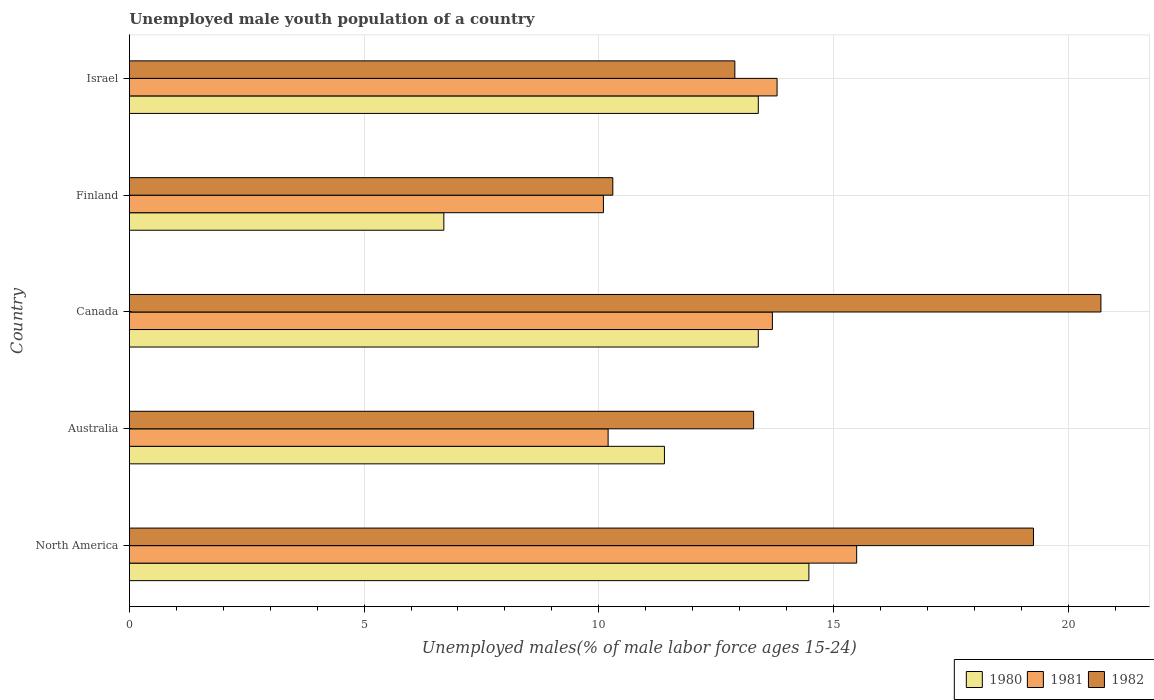Are the number of bars per tick equal to the number of legend labels?
Give a very brief answer. Yes. Are the number of bars on each tick of the Y-axis equal?
Your response must be concise. Yes. How many bars are there on the 1st tick from the top?
Your answer should be very brief. 3. In how many cases, is the number of bars for a given country not equal to the number of legend labels?
Your response must be concise. 0. What is the percentage of unemployed male youth population in 1982 in Australia?
Your answer should be compact. 13.3. Across all countries, what is the maximum percentage of unemployed male youth population in 1980?
Your answer should be compact. 14.48. Across all countries, what is the minimum percentage of unemployed male youth population in 1980?
Offer a terse response. 6.7. In which country was the percentage of unemployed male youth population in 1982 maximum?
Your answer should be compact. Canada. In which country was the percentage of unemployed male youth population in 1982 minimum?
Ensure brevity in your answer.  Finland. What is the total percentage of unemployed male youth population in 1981 in the graph?
Provide a short and direct response. 63.3. What is the difference between the percentage of unemployed male youth population in 1982 in Australia and that in North America?
Make the answer very short. -5.96. What is the difference between the percentage of unemployed male youth population in 1980 in North America and the percentage of unemployed male youth population in 1982 in Canada?
Ensure brevity in your answer.  -6.22. What is the average percentage of unemployed male youth population in 1981 per country?
Your answer should be compact. 12.66. What is the difference between the percentage of unemployed male youth population in 1982 and percentage of unemployed male youth population in 1980 in North America?
Provide a short and direct response. 4.79. In how many countries, is the percentage of unemployed male youth population in 1981 greater than 12 %?
Your response must be concise. 3. What is the ratio of the percentage of unemployed male youth population in 1980 in Canada to that in Finland?
Keep it short and to the point. 2. Is the percentage of unemployed male youth population in 1982 in Finland less than that in Israel?
Ensure brevity in your answer.  Yes. Is the difference between the percentage of unemployed male youth population in 1982 in Australia and Finland greater than the difference between the percentage of unemployed male youth population in 1980 in Australia and Finland?
Your answer should be very brief. No. What is the difference between the highest and the second highest percentage of unemployed male youth population in 1982?
Make the answer very short. 1.44. What is the difference between the highest and the lowest percentage of unemployed male youth population in 1981?
Offer a terse response. 5.4. Is the sum of the percentage of unemployed male youth population in 1982 in Canada and North America greater than the maximum percentage of unemployed male youth population in 1981 across all countries?
Provide a short and direct response. Yes. What does the 2nd bar from the bottom in Finland represents?
Your answer should be compact. 1981. Are all the bars in the graph horizontal?
Provide a short and direct response. Yes. What is the difference between two consecutive major ticks on the X-axis?
Provide a short and direct response. 5. Does the graph contain any zero values?
Your answer should be compact. No. Does the graph contain grids?
Your response must be concise. Yes. Where does the legend appear in the graph?
Your answer should be compact. Bottom right. How many legend labels are there?
Provide a succinct answer. 3. How are the legend labels stacked?
Give a very brief answer. Horizontal. What is the title of the graph?
Make the answer very short. Unemployed male youth population of a country. Does "1980" appear as one of the legend labels in the graph?
Provide a short and direct response. Yes. What is the label or title of the X-axis?
Your answer should be very brief. Unemployed males(% of male labor force ages 15-24). What is the Unemployed males(% of male labor force ages 15-24) in 1980 in North America?
Your answer should be very brief. 14.48. What is the Unemployed males(% of male labor force ages 15-24) in 1981 in North America?
Provide a short and direct response. 15.5. What is the Unemployed males(% of male labor force ages 15-24) in 1982 in North America?
Your answer should be very brief. 19.26. What is the Unemployed males(% of male labor force ages 15-24) in 1980 in Australia?
Your response must be concise. 11.4. What is the Unemployed males(% of male labor force ages 15-24) of 1981 in Australia?
Make the answer very short. 10.2. What is the Unemployed males(% of male labor force ages 15-24) in 1982 in Australia?
Offer a terse response. 13.3. What is the Unemployed males(% of male labor force ages 15-24) in 1980 in Canada?
Offer a terse response. 13.4. What is the Unemployed males(% of male labor force ages 15-24) of 1981 in Canada?
Your answer should be very brief. 13.7. What is the Unemployed males(% of male labor force ages 15-24) in 1982 in Canada?
Provide a short and direct response. 20.7. What is the Unemployed males(% of male labor force ages 15-24) of 1980 in Finland?
Offer a terse response. 6.7. What is the Unemployed males(% of male labor force ages 15-24) in 1981 in Finland?
Provide a succinct answer. 10.1. What is the Unemployed males(% of male labor force ages 15-24) of 1982 in Finland?
Your answer should be compact. 10.3. What is the Unemployed males(% of male labor force ages 15-24) of 1980 in Israel?
Ensure brevity in your answer.  13.4. What is the Unemployed males(% of male labor force ages 15-24) in 1981 in Israel?
Ensure brevity in your answer.  13.8. What is the Unemployed males(% of male labor force ages 15-24) of 1982 in Israel?
Give a very brief answer. 12.9. Across all countries, what is the maximum Unemployed males(% of male labor force ages 15-24) in 1980?
Make the answer very short. 14.48. Across all countries, what is the maximum Unemployed males(% of male labor force ages 15-24) of 1981?
Your answer should be compact. 15.5. Across all countries, what is the maximum Unemployed males(% of male labor force ages 15-24) in 1982?
Provide a succinct answer. 20.7. Across all countries, what is the minimum Unemployed males(% of male labor force ages 15-24) of 1980?
Ensure brevity in your answer.  6.7. Across all countries, what is the minimum Unemployed males(% of male labor force ages 15-24) in 1981?
Your answer should be very brief. 10.1. Across all countries, what is the minimum Unemployed males(% of male labor force ages 15-24) of 1982?
Give a very brief answer. 10.3. What is the total Unemployed males(% of male labor force ages 15-24) in 1980 in the graph?
Give a very brief answer. 59.38. What is the total Unemployed males(% of male labor force ages 15-24) in 1981 in the graph?
Provide a short and direct response. 63.3. What is the total Unemployed males(% of male labor force ages 15-24) in 1982 in the graph?
Provide a short and direct response. 76.46. What is the difference between the Unemployed males(% of male labor force ages 15-24) in 1980 in North America and that in Australia?
Your answer should be compact. 3.08. What is the difference between the Unemployed males(% of male labor force ages 15-24) in 1981 in North America and that in Australia?
Your answer should be compact. 5.3. What is the difference between the Unemployed males(% of male labor force ages 15-24) in 1982 in North America and that in Australia?
Offer a terse response. 5.96. What is the difference between the Unemployed males(% of male labor force ages 15-24) in 1980 in North America and that in Canada?
Keep it short and to the point. 1.08. What is the difference between the Unemployed males(% of male labor force ages 15-24) of 1981 in North America and that in Canada?
Keep it short and to the point. 1.8. What is the difference between the Unemployed males(% of male labor force ages 15-24) in 1982 in North America and that in Canada?
Offer a very short reply. -1.44. What is the difference between the Unemployed males(% of male labor force ages 15-24) of 1980 in North America and that in Finland?
Your answer should be compact. 7.78. What is the difference between the Unemployed males(% of male labor force ages 15-24) of 1981 in North America and that in Finland?
Keep it short and to the point. 5.4. What is the difference between the Unemployed males(% of male labor force ages 15-24) of 1982 in North America and that in Finland?
Your response must be concise. 8.96. What is the difference between the Unemployed males(% of male labor force ages 15-24) of 1980 in North America and that in Israel?
Keep it short and to the point. 1.08. What is the difference between the Unemployed males(% of male labor force ages 15-24) of 1981 in North America and that in Israel?
Provide a succinct answer. 1.7. What is the difference between the Unemployed males(% of male labor force ages 15-24) of 1982 in North America and that in Israel?
Offer a terse response. 6.36. What is the difference between the Unemployed males(% of male labor force ages 15-24) in 1980 in Australia and that in Canada?
Your answer should be very brief. -2. What is the difference between the Unemployed males(% of male labor force ages 15-24) of 1982 in Australia and that in Canada?
Your response must be concise. -7.4. What is the difference between the Unemployed males(% of male labor force ages 15-24) in 1982 in Australia and that in Finland?
Your response must be concise. 3. What is the difference between the Unemployed males(% of male labor force ages 15-24) of 1981 in Australia and that in Israel?
Offer a terse response. -3.6. What is the difference between the Unemployed males(% of male labor force ages 15-24) of 1981 in Canada and that in Finland?
Offer a terse response. 3.6. What is the difference between the Unemployed males(% of male labor force ages 15-24) in 1980 in Canada and that in Israel?
Provide a succinct answer. 0. What is the difference between the Unemployed males(% of male labor force ages 15-24) of 1982 in Finland and that in Israel?
Provide a short and direct response. -2.6. What is the difference between the Unemployed males(% of male labor force ages 15-24) of 1980 in North America and the Unemployed males(% of male labor force ages 15-24) of 1981 in Australia?
Give a very brief answer. 4.28. What is the difference between the Unemployed males(% of male labor force ages 15-24) of 1980 in North America and the Unemployed males(% of male labor force ages 15-24) of 1982 in Australia?
Keep it short and to the point. 1.18. What is the difference between the Unemployed males(% of male labor force ages 15-24) in 1981 in North America and the Unemployed males(% of male labor force ages 15-24) in 1982 in Australia?
Give a very brief answer. 2.2. What is the difference between the Unemployed males(% of male labor force ages 15-24) of 1980 in North America and the Unemployed males(% of male labor force ages 15-24) of 1981 in Canada?
Your response must be concise. 0.78. What is the difference between the Unemployed males(% of male labor force ages 15-24) in 1980 in North America and the Unemployed males(% of male labor force ages 15-24) in 1982 in Canada?
Your answer should be very brief. -6.22. What is the difference between the Unemployed males(% of male labor force ages 15-24) of 1981 in North America and the Unemployed males(% of male labor force ages 15-24) of 1982 in Canada?
Give a very brief answer. -5.2. What is the difference between the Unemployed males(% of male labor force ages 15-24) of 1980 in North America and the Unemployed males(% of male labor force ages 15-24) of 1981 in Finland?
Offer a very short reply. 4.38. What is the difference between the Unemployed males(% of male labor force ages 15-24) in 1980 in North America and the Unemployed males(% of male labor force ages 15-24) in 1982 in Finland?
Your answer should be compact. 4.18. What is the difference between the Unemployed males(% of male labor force ages 15-24) in 1981 in North America and the Unemployed males(% of male labor force ages 15-24) in 1982 in Finland?
Offer a terse response. 5.2. What is the difference between the Unemployed males(% of male labor force ages 15-24) in 1980 in North America and the Unemployed males(% of male labor force ages 15-24) in 1981 in Israel?
Offer a very short reply. 0.68. What is the difference between the Unemployed males(% of male labor force ages 15-24) in 1980 in North America and the Unemployed males(% of male labor force ages 15-24) in 1982 in Israel?
Ensure brevity in your answer.  1.58. What is the difference between the Unemployed males(% of male labor force ages 15-24) of 1981 in North America and the Unemployed males(% of male labor force ages 15-24) of 1982 in Israel?
Provide a succinct answer. 2.6. What is the difference between the Unemployed males(% of male labor force ages 15-24) of 1980 in Australia and the Unemployed males(% of male labor force ages 15-24) of 1982 in Canada?
Offer a very short reply. -9.3. What is the difference between the Unemployed males(% of male labor force ages 15-24) of 1980 in Australia and the Unemployed males(% of male labor force ages 15-24) of 1981 in Finland?
Give a very brief answer. 1.3. What is the difference between the Unemployed males(% of male labor force ages 15-24) of 1980 in Australia and the Unemployed males(% of male labor force ages 15-24) of 1982 in Israel?
Keep it short and to the point. -1.5. What is the difference between the Unemployed males(% of male labor force ages 15-24) in 1980 in Canada and the Unemployed males(% of male labor force ages 15-24) in 1981 in Finland?
Give a very brief answer. 3.3. What is the difference between the Unemployed males(% of male labor force ages 15-24) in 1980 in Canada and the Unemployed males(% of male labor force ages 15-24) in 1982 in Finland?
Give a very brief answer. 3.1. What is the difference between the Unemployed males(% of male labor force ages 15-24) in 1980 in Canada and the Unemployed males(% of male labor force ages 15-24) in 1982 in Israel?
Give a very brief answer. 0.5. What is the difference between the Unemployed males(% of male labor force ages 15-24) in 1980 in Finland and the Unemployed males(% of male labor force ages 15-24) in 1981 in Israel?
Offer a terse response. -7.1. What is the difference between the Unemployed males(% of male labor force ages 15-24) in 1981 in Finland and the Unemployed males(% of male labor force ages 15-24) in 1982 in Israel?
Your answer should be very brief. -2.8. What is the average Unemployed males(% of male labor force ages 15-24) in 1980 per country?
Offer a terse response. 11.88. What is the average Unemployed males(% of male labor force ages 15-24) of 1981 per country?
Your answer should be compact. 12.66. What is the average Unemployed males(% of male labor force ages 15-24) of 1982 per country?
Your response must be concise. 15.29. What is the difference between the Unemployed males(% of male labor force ages 15-24) of 1980 and Unemployed males(% of male labor force ages 15-24) of 1981 in North America?
Keep it short and to the point. -1.02. What is the difference between the Unemployed males(% of male labor force ages 15-24) of 1980 and Unemployed males(% of male labor force ages 15-24) of 1982 in North America?
Your answer should be very brief. -4.79. What is the difference between the Unemployed males(% of male labor force ages 15-24) in 1981 and Unemployed males(% of male labor force ages 15-24) in 1982 in North America?
Your answer should be very brief. -3.77. What is the difference between the Unemployed males(% of male labor force ages 15-24) of 1980 and Unemployed males(% of male labor force ages 15-24) of 1982 in Australia?
Keep it short and to the point. -1.9. What is the difference between the Unemployed males(% of male labor force ages 15-24) of 1981 and Unemployed males(% of male labor force ages 15-24) of 1982 in Australia?
Keep it short and to the point. -3.1. What is the difference between the Unemployed males(% of male labor force ages 15-24) in 1980 and Unemployed males(% of male labor force ages 15-24) in 1981 in Canada?
Keep it short and to the point. -0.3. What is the difference between the Unemployed males(% of male labor force ages 15-24) of 1980 and Unemployed males(% of male labor force ages 15-24) of 1982 in Canada?
Your answer should be very brief. -7.3. What is the difference between the Unemployed males(% of male labor force ages 15-24) in 1981 and Unemployed males(% of male labor force ages 15-24) in 1982 in Canada?
Keep it short and to the point. -7. What is the difference between the Unemployed males(% of male labor force ages 15-24) in 1980 and Unemployed males(% of male labor force ages 15-24) in 1981 in Finland?
Provide a short and direct response. -3.4. What is the difference between the Unemployed males(% of male labor force ages 15-24) in 1981 and Unemployed males(% of male labor force ages 15-24) in 1982 in Finland?
Your response must be concise. -0.2. What is the difference between the Unemployed males(% of male labor force ages 15-24) in 1980 and Unemployed males(% of male labor force ages 15-24) in 1982 in Israel?
Give a very brief answer. 0.5. What is the ratio of the Unemployed males(% of male labor force ages 15-24) of 1980 in North America to that in Australia?
Keep it short and to the point. 1.27. What is the ratio of the Unemployed males(% of male labor force ages 15-24) in 1981 in North America to that in Australia?
Offer a very short reply. 1.52. What is the ratio of the Unemployed males(% of male labor force ages 15-24) in 1982 in North America to that in Australia?
Provide a succinct answer. 1.45. What is the ratio of the Unemployed males(% of male labor force ages 15-24) of 1980 in North America to that in Canada?
Your answer should be very brief. 1.08. What is the ratio of the Unemployed males(% of male labor force ages 15-24) of 1981 in North America to that in Canada?
Keep it short and to the point. 1.13. What is the ratio of the Unemployed males(% of male labor force ages 15-24) in 1982 in North America to that in Canada?
Provide a succinct answer. 0.93. What is the ratio of the Unemployed males(% of male labor force ages 15-24) in 1980 in North America to that in Finland?
Provide a short and direct response. 2.16. What is the ratio of the Unemployed males(% of male labor force ages 15-24) in 1981 in North America to that in Finland?
Offer a very short reply. 1.53. What is the ratio of the Unemployed males(% of male labor force ages 15-24) in 1982 in North America to that in Finland?
Give a very brief answer. 1.87. What is the ratio of the Unemployed males(% of male labor force ages 15-24) of 1980 in North America to that in Israel?
Ensure brevity in your answer.  1.08. What is the ratio of the Unemployed males(% of male labor force ages 15-24) in 1981 in North America to that in Israel?
Provide a short and direct response. 1.12. What is the ratio of the Unemployed males(% of male labor force ages 15-24) in 1982 in North America to that in Israel?
Offer a terse response. 1.49. What is the ratio of the Unemployed males(% of male labor force ages 15-24) of 1980 in Australia to that in Canada?
Your answer should be very brief. 0.85. What is the ratio of the Unemployed males(% of male labor force ages 15-24) in 1981 in Australia to that in Canada?
Provide a short and direct response. 0.74. What is the ratio of the Unemployed males(% of male labor force ages 15-24) in 1982 in Australia to that in Canada?
Offer a terse response. 0.64. What is the ratio of the Unemployed males(% of male labor force ages 15-24) in 1980 in Australia to that in Finland?
Offer a terse response. 1.7. What is the ratio of the Unemployed males(% of male labor force ages 15-24) in 1981 in Australia to that in Finland?
Your answer should be very brief. 1.01. What is the ratio of the Unemployed males(% of male labor force ages 15-24) in 1982 in Australia to that in Finland?
Keep it short and to the point. 1.29. What is the ratio of the Unemployed males(% of male labor force ages 15-24) in 1980 in Australia to that in Israel?
Provide a short and direct response. 0.85. What is the ratio of the Unemployed males(% of male labor force ages 15-24) of 1981 in Australia to that in Israel?
Offer a very short reply. 0.74. What is the ratio of the Unemployed males(% of male labor force ages 15-24) in 1982 in Australia to that in Israel?
Provide a succinct answer. 1.03. What is the ratio of the Unemployed males(% of male labor force ages 15-24) in 1980 in Canada to that in Finland?
Give a very brief answer. 2. What is the ratio of the Unemployed males(% of male labor force ages 15-24) in 1981 in Canada to that in Finland?
Give a very brief answer. 1.36. What is the ratio of the Unemployed males(% of male labor force ages 15-24) in 1982 in Canada to that in Finland?
Make the answer very short. 2.01. What is the ratio of the Unemployed males(% of male labor force ages 15-24) of 1980 in Canada to that in Israel?
Your answer should be compact. 1. What is the ratio of the Unemployed males(% of male labor force ages 15-24) in 1982 in Canada to that in Israel?
Your response must be concise. 1.6. What is the ratio of the Unemployed males(% of male labor force ages 15-24) in 1981 in Finland to that in Israel?
Your answer should be compact. 0.73. What is the ratio of the Unemployed males(% of male labor force ages 15-24) in 1982 in Finland to that in Israel?
Offer a terse response. 0.8. What is the difference between the highest and the second highest Unemployed males(% of male labor force ages 15-24) in 1980?
Your response must be concise. 1.08. What is the difference between the highest and the second highest Unemployed males(% of male labor force ages 15-24) of 1981?
Keep it short and to the point. 1.7. What is the difference between the highest and the second highest Unemployed males(% of male labor force ages 15-24) in 1982?
Provide a short and direct response. 1.44. What is the difference between the highest and the lowest Unemployed males(% of male labor force ages 15-24) of 1980?
Your response must be concise. 7.78. What is the difference between the highest and the lowest Unemployed males(% of male labor force ages 15-24) in 1981?
Offer a very short reply. 5.4. What is the difference between the highest and the lowest Unemployed males(% of male labor force ages 15-24) in 1982?
Your response must be concise. 10.4. 